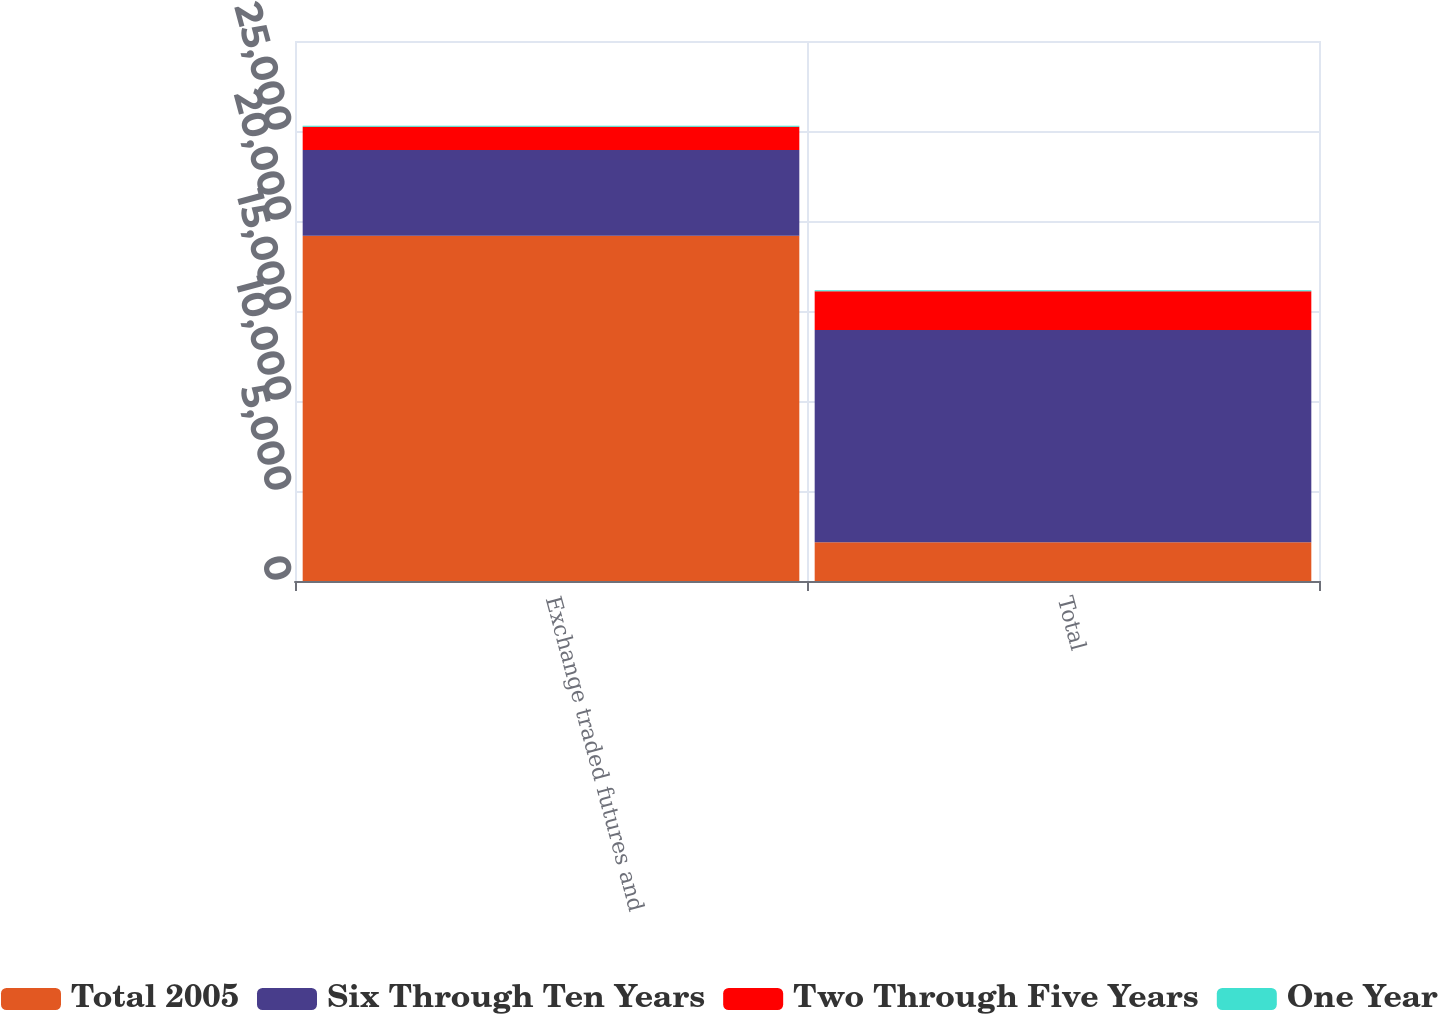Convert chart to OTSL. <chart><loc_0><loc_0><loc_500><loc_500><stacked_bar_chart><ecel><fcel>Exchange traded futures and<fcel>Total<nl><fcel>Total 2005<fcel>19182<fcel>2154<nl><fcel>Six Through Ten Years<fcel>4768<fcel>11785<nl><fcel>Two Through Five Years<fcel>1287<fcel>2154<nl><fcel>One Year<fcel>61<fcel>61<nl></chart> 